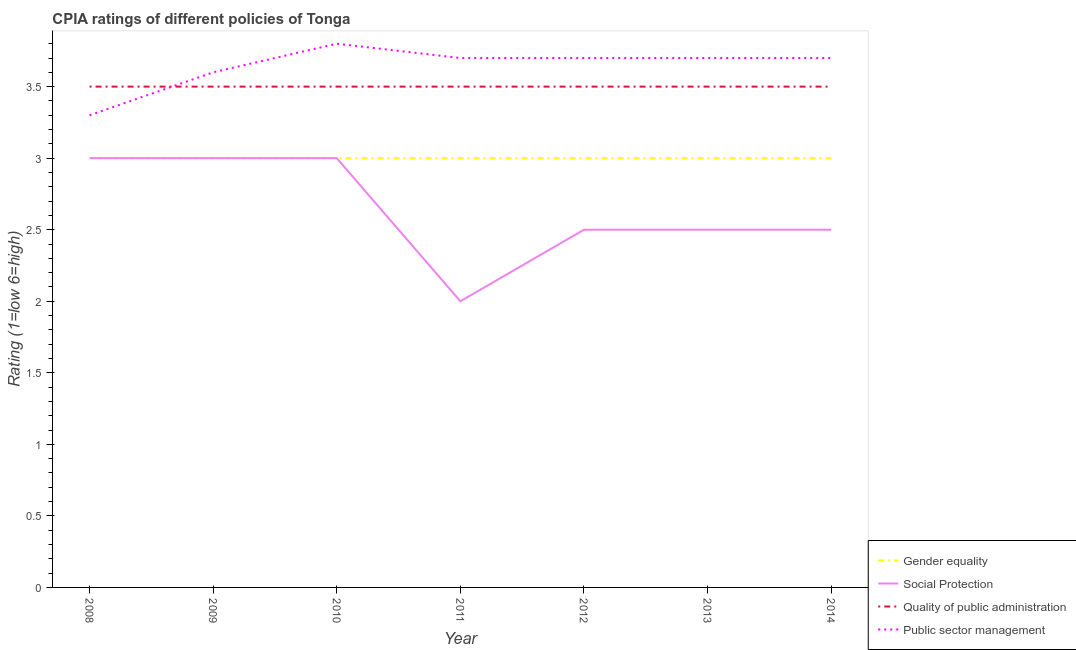How many different coloured lines are there?
Your answer should be very brief. 4. Is the number of lines equal to the number of legend labels?
Your answer should be compact. Yes. Across all years, what is the minimum cpia rating of quality of public administration?
Your answer should be compact. 3.5. In which year was the cpia rating of quality of public administration minimum?
Keep it short and to the point. 2008. What is the difference between the cpia rating of social protection in 2013 and that in 2014?
Provide a short and direct response. 0. What is the difference between the cpia rating of gender equality in 2009 and the cpia rating of quality of public administration in 2010?
Ensure brevity in your answer.  -0.5. What is the average cpia rating of public sector management per year?
Offer a terse response. 3.64. In the year 2009, what is the difference between the cpia rating of public sector management and cpia rating of gender equality?
Offer a very short reply. 0.6. In how many years, is the cpia rating of quality of public administration greater than 2.8?
Your answer should be compact. 7. Is the difference between the cpia rating of public sector management in 2013 and 2014 greater than the difference between the cpia rating of social protection in 2013 and 2014?
Make the answer very short. No. What is the difference between the highest and the second highest cpia rating of public sector management?
Offer a very short reply. 0.1. In how many years, is the cpia rating of gender equality greater than the average cpia rating of gender equality taken over all years?
Your answer should be compact. 0. Is it the case that in every year, the sum of the cpia rating of gender equality and cpia rating of social protection is greater than the cpia rating of quality of public administration?
Your answer should be very brief. Yes. How many years are there in the graph?
Ensure brevity in your answer.  7. What is the difference between two consecutive major ticks on the Y-axis?
Provide a succinct answer. 0.5. Are the values on the major ticks of Y-axis written in scientific E-notation?
Your answer should be very brief. No. How many legend labels are there?
Keep it short and to the point. 4. How are the legend labels stacked?
Provide a short and direct response. Vertical. What is the title of the graph?
Provide a short and direct response. CPIA ratings of different policies of Tonga. Does "Fiscal policy" appear as one of the legend labels in the graph?
Offer a terse response. No. What is the label or title of the X-axis?
Keep it short and to the point. Year. What is the Rating (1=low 6=high) in Social Protection in 2008?
Keep it short and to the point. 3. What is the Rating (1=low 6=high) of Quality of public administration in 2008?
Provide a short and direct response. 3.5. What is the Rating (1=low 6=high) in Public sector management in 2008?
Your answer should be compact. 3.3. What is the Rating (1=low 6=high) of Gender equality in 2009?
Offer a terse response. 3. What is the Rating (1=low 6=high) of Quality of public administration in 2009?
Give a very brief answer. 3.5. What is the Rating (1=low 6=high) in Public sector management in 2009?
Your response must be concise. 3.6. What is the Rating (1=low 6=high) of Social Protection in 2010?
Keep it short and to the point. 3. What is the Rating (1=low 6=high) in Quality of public administration in 2011?
Your answer should be compact. 3.5. What is the Rating (1=low 6=high) in Public sector management in 2011?
Make the answer very short. 3.7. What is the Rating (1=low 6=high) of Gender equality in 2012?
Your answer should be compact. 3. What is the Rating (1=low 6=high) of Quality of public administration in 2012?
Offer a terse response. 3.5. What is the Rating (1=low 6=high) of Public sector management in 2012?
Your response must be concise. 3.7. What is the Rating (1=low 6=high) of Gender equality in 2013?
Your response must be concise. 3. What is the Rating (1=low 6=high) in Gender equality in 2014?
Keep it short and to the point. 3. What is the Rating (1=low 6=high) in Social Protection in 2014?
Offer a terse response. 2.5. What is the Rating (1=low 6=high) in Quality of public administration in 2014?
Your answer should be very brief. 3.5. What is the Rating (1=low 6=high) of Public sector management in 2014?
Your response must be concise. 3.7. Across all years, what is the maximum Rating (1=low 6=high) of Gender equality?
Offer a terse response. 3. Across all years, what is the maximum Rating (1=low 6=high) in Social Protection?
Give a very brief answer. 3. Across all years, what is the maximum Rating (1=low 6=high) of Public sector management?
Keep it short and to the point. 3.8. Across all years, what is the minimum Rating (1=low 6=high) in Social Protection?
Your answer should be very brief. 2. Across all years, what is the minimum Rating (1=low 6=high) of Quality of public administration?
Provide a short and direct response. 3.5. What is the total Rating (1=low 6=high) in Social Protection in the graph?
Provide a short and direct response. 18.5. What is the difference between the Rating (1=low 6=high) in Gender equality in 2008 and that in 2009?
Provide a succinct answer. 0. What is the difference between the Rating (1=low 6=high) in Quality of public administration in 2008 and that in 2009?
Provide a short and direct response. 0. What is the difference between the Rating (1=low 6=high) of Gender equality in 2008 and that in 2010?
Your answer should be compact. 0. What is the difference between the Rating (1=low 6=high) of Social Protection in 2008 and that in 2010?
Your answer should be compact. 0. What is the difference between the Rating (1=low 6=high) in Public sector management in 2008 and that in 2010?
Provide a short and direct response. -0.5. What is the difference between the Rating (1=low 6=high) in Gender equality in 2008 and that in 2011?
Give a very brief answer. 0. What is the difference between the Rating (1=low 6=high) in Social Protection in 2008 and that in 2011?
Provide a short and direct response. 1. What is the difference between the Rating (1=low 6=high) of Quality of public administration in 2008 and that in 2011?
Provide a succinct answer. 0. What is the difference between the Rating (1=low 6=high) in Public sector management in 2008 and that in 2011?
Your response must be concise. -0.4. What is the difference between the Rating (1=low 6=high) of Gender equality in 2008 and that in 2012?
Provide a succinct answer. 0. What is the difference between the Rating (1=low 6=high) in Social Protection in 2008 and that in 2012?
Your answer should be very brief. 0.5. What is the difference between the Rating (1=low 6=high) of Quality of public administration in 2008 and that in 2012?
Your answer should be very brief. 0. What is the difference between the Rating (1=low 6=high) of Quality of public administration in 2008 and that in 2013?
Keep it short and to the point. 0. What is the difference between the Rating (1=low 6=high) of Public sector management in 2008 and that in 2013?
Provide a succinct answer. -0.4. What is the difference between the Rating (1=low 6=high) of Gender equality in 2009 and that in 2010?
Offer a very short reply. 0. What is the difference between the Rating (1=low 6=high) of Social Protection in 2009 and that in 2010?
Keep it short and to the point. 0. What is the difference between the Rating (1=low 6=high) in Quality of public administration in 2009 and that in 2010?
Make the answer very short. 0. What is the difference between the Rating (1=low 6=high) in Public sector management in 2009 and that in 2010?
Offer a terse response. -0.2. What is the difference between the Rating (1=low 6=high) of Gender equality in 2009 and that in 2011?
Give a very brief answer. 0. What is the difference between the Rating (1=low 6=high) of Gender equality in 2009 and that in 2012?
Make the answer very short. 0. What is the difference between the Rating (1=low 6=high) of Quality of public administration in 2009 and that in 2012?
Your response must be concise. 0. What is the difference between the Rating (1=low 6=high) of Public sector management in 2009 and that in 2012?
Your answer should be compact. -0.1. What is the difference between the Rating (1=low 6=high) of Social Protection in 2009 and that in 2013?
Ensure brevity in your answer.  0.5. What is the difference between the Rating (1=low 6=high) of Public sector management in 2009 and that in 2013?
Your answer should be compact. -0.1. What is the difference between the Rating (1=low 6=high) of Social Protection in 2009 and that in 2014?
Your answer should be compact. 0.5. What is the difference between the Rating (1=low 6=high) of Social Protection in 2010 and that in 2011?
Your response must be concise. 1. What is the difference between the Rating (1=low 6=high) of Quality of public administration in 2010 and that in 2011?
Your answer should be compact. 0. What is the difference between the Rating (1=low 6=high) of Gender equality in 2010 and that in 2012?
Provide a succinct answer. 0. What is the difference between the Rating (1=low 6=high) in Public sector management in 2010 and that in 2012?
Your answer should be very brief. 0.1. What is the difference between the Rating (1=low 6=high) in Gender equality in 2010 and that in 2013?
Your answer should be compact. 0. What is the difference between the Rating (1=low 6=high) in Social Protection in 2010 and that in 2014?
Your answer should be very brief. 0.5. What is the difference between the Rating (1=low 6=high) in Quality of public administration in 2010 and that in 2014?
Provide a succinct answer. 0. What is the difference between the Rating (1=low 6=high) of Gender equality in 2011 and that in 2012?
Offer a terse response. 0. What is the difference between the Rating (1=low 6=high) in Social Protection in 2011 and that in 2012?
Give a very brief answer. -0.5. What is the difference between the Rating (1=low 6=high) of Quality of public administration in 2011 and that in 2012?
Provide a short and direct response. 0. What is the difference between the Rating (1=low 6=high) of Public sector management in 2011 and that in 2013?
Give a very brief answer. 0. What is the difference between the Rating (1=low 6=high) in Social Protection in 2011 and that in 2014?
Ensure brevity in your answer.  -0.5. What is the difference between the Rating (1=low 6=high) in Quality of public administration in 2011 and that in 2014?
Your answer should be compact. 0. What is the difference between the Rating (1=low 6=high) in Gender equality in 2012 and that in 2013?
Make the answer very short. 0. What is the difference between the Rating (1=low 6=high) of Quality of public administration in 2012 and that in 2013?
Keep it short and to the point. 0. What is the difference between the Rating (1=low 6=high) of Public sector management in 2012 and that in 2013?
Ensure brevity in your answer.  0. What is the difference between the Rating (1=low 6=high) of Gender equality in 2012 and that in 2014?
Provide a short and direct response. 0. What is the difference between the Rating (1=low 6=high) of Quality of public administration in 2012 and that in 2014?
Provide a short and direct response. 0. What is the difference between the Rating (1=low 6=high) of Public sector management in 2013 and that in 2014?
Your response must be concise. 0. What is the difference between the Rating (1=low 6=high) of Gender equality in 2008 and the Rating (1=low 6=high) of Social Protection in 2009?
Your answer should be compact. 0. What is the difference between the Rating (1=low 6=high) of Gender equality in 2008 and the Rating (1=low 6=high) of Public sector management in 2009?
Offer a terse response. -0.6. What is the difference between the Rating (1=low 6=high) in Gender equality in 2008 and the Rating (1=low 6=high) in Quality of public administration in 2010?
Offer a terse response. -0.5. What is the difference between the Rating (1=low 6=high) of Social Protection in 2008 and the Rating (1=low 6=high) of Quality of public administration in 2010?
Your answer should be compact. -0.5. What is the difference between the Rating (1=low 6=high) of Social Protection in 2008 and the Rating (1=low 6=high) of Public sector management in 2010?
Provide a short and direct response. -0.8. What is the difference between the Rating (1=low 6=high) in Quality of public administration in 2008 and the Rating (1=low 6=high) in Public sector management in 2010?
Ensure brevity in your answer.  -0.3. What is the difference between the Rating (1=low 6=high) in Gender equality in 2008 and the Rating (1=low 6=high) in Social Protection in 2011?
Provide a short and direct response. 1. What is the difference between the Rating (1=low 6=high) of Gender equality in 2008 and the Rating (1=low 6=high) of Public sector management in 2011?
Your response must be concise. -0.7. What is the difference between the Rating (1=low 6=high) in Social Protection in 2008 and the Rating (1=low 6=high) in Public sector management in 2011?
Ensure brevity in your answer.  -0.7. What is the difference between the Rating (1=low 6=high) in Quality of public administration in 2008 and the Rating (1=low 6=high) in Public sector management in 2011?
Offer a terse response. -0.2. What is the difference between the Rating (1=low 6=high) of Gender equality in 2008 and the Rating (1=low 6=high) of Social Protection in 2012?
Your response must be concise. 0.5. What is the difference between the Rating (1=low 6=high) of Gender equality in 2008 and the Rating (1=low 6=high) of Public sector management in 2012?
Give a very brief answer. -0.7. What is the difference between the Rating (1=low 6=high) of Social Protection in 2008 and the Rating (1=low 6=high) of Public sector management in 2012?
Your response must be concise. -0.7. What is the difference between the Rating (1=low 6=high) in Quality of public administration in 2008 and the Rating (1=low 6=high) in Public sector management in 2012?
Keep it short and to the point. -0.2. What is the difference between the Rating (1=low 6=high) of Gender equality in 2008 and the Rating (1=low 6=high) of Social Protection in 2013?
Offer a terse response. 0.5. What is the difference between the Rating (1=low 6=high) in Gender equality in 2008 and the Rating (1=low 6=high) in Public sector management in 2013?
Provide a short and direct response. -0.7. What is the difference between the Rating (1=low 6=high) in Gender equality in 2008 and the Rating (1=low 6=high) in Social Protection in 2014?
Your response must be concise. 0.5. What is the difference between the Rating (1=low 6=high) in Gender equality in 2008 and the Rating (1=low 6=high) in Quality of public administration in 2014?
Offer a very short reply. -0.5. What is the difference between the Rating (1=low 6=high) in Social Protection in 2008 and the Rating (1=low 6=high) in Quality of public administration in 2014?
Make the answer very short. -0.5. What is the difference between the Rating (1=low 6=high) in Quality of public administration in 2008 and the Rating (1=low 6=high) in Public sector management in 2014?
Give a very brief answer. -0.2. What is the difference between the Rating (1=low 6=high) in Gender equality in 2009 and the Rating (1=low 6=high) in Social Protection in 2010?
Your answer should be compact. 0. What is the difference between the Rating (1=low 6=high) of Gender equality in 2009 and the Rating (1=low 6=high) of Quality of public administration in 2010?
Keep it short and to the point. -0.5. What is the difference between the Rating (1=low 6=high) in Social Protection in 2009 and the Rating (1=low 6=high) in Public sector management in 2010?
Offer a terse response. -0.8. What is the difference between the Rating (1=low 6=high) of Gender equality in 2009 and the Rating (1=low 6=high) of Public sector management in 2011?
Your response must be concise. -0.7. What is the difference between the Rating (1=low 6=high) in Quality of public administration in 2009 and the Rating (1=low 6=high) in Public sector management in 2011?
Give a very brief answer. -0.2. What is the difference between the Rating (1=low 6=high) in Gender equality in 2009 and the Rating (1=low 6=high) in Quality of public administration in 2012?
Your response must be concise. -0.5. What is the difference between the Rating (1=low 6=high) of Gender equality in 2009 and the Rating (1=low 6=high) of Public sector management in 2012?
Offer a terse response. -0.7. What is the difference between the Rating (1=low 6=high) in Social Protection in 2009 and the Rating (1=low 6=high) in Public sector management in 2012?
Ensure brevity in your answer.  -0.7. What is the difference between the Rating (1=low 6=high) in Quality of public administration in 2009 and the Rating (1=low 6=high) in Public sector management in 2012?
Ensure brevity in your answer.  -0.2. What is the difference between the Rating (1=low 6=high) in Gender equality in 2009 and the Rating (1=low 6=high) in Quality of public administration in 2013?
Give a very brief answer. -0.5. What is the difference between the Rating (1=low 6=high) in Gender equality in 2009 and the Rating (1=low 6=high) in Public sector management in 2013?
Provide a short and direct response. -0.7. What is the difference between the Rating (1=low 6=high) of Quality of public administration in 2009 and the Rating (1=low 6=high) of Public sector management in 2013?
Make the answer very short. -0.2. What is the difference between the Rating (1=low 6=high) in Social Protection in 2009 and the Rating (1=low 6=high) in Public sector management in 2014?
Your response must be concise. -0.7. What is the difference between the Rating (1=low 6=high) in Social Protection in 2010 and the Rating (1=low 6=high) in Quality of public administration in 2011?
Provide a short and direct response. -0.5. What is the difference between the Rating (1=low 6=high) of Social Protection in 2010 and the Rating (1=low 6=high) of Public sector management in 2011?
Offer a very short reply. -0.7. What is the difference between the Rating (1=low 6=high) of Gender equality in 2010 and the Rating (1=low 6=high) of Social Protection in 2012?
Your answer should be very brief. 0.5. What is the difference between the Rating (1=low 6=high) in Gender equality in 2010 and the Rating (1=low 6=high) in Quality of public administration in 2012?
Your response must be concise. -0.5. What is the difference between the Rating (1=low 6=high) in Social Protection in 2010 and the Rating (1=low 6=high) in Public sector management in 2012?
Offer a terse response. -0.7. What is the difference between the Rating (1=low 6=high) in Gender equality in 2010 and the Rating (1=low 6=high) in Quality of public administration in 2013?
Ensure brevity in your answer.  -0.5. What is the difference between the Rating (1=low 6=high) of Gender equality in 2010 and the Rating (1=low 6=high) of Public sector management in 2013?
Keep it short and to the point. -0.7. What is the difference between the Rating (1=low 6=high) of Quality of public administration in 2010 and the Rating (1=low 6=high) of Public sector management in 2013?
Give a very brief answer. -0.2. What is the difference between the Rating (1=low 6=high) in Gender equality in 2010 and the Rating (1=low 6=high) in Social Protection in 2014?
Your answer should be very brief. 0.5. What is the difference between the Rating (1=low 6=high) of Gender equality in 2010 and the Rating (1=low 6=high) of Quality of public administration in 2014?
Provide a short and direct response. -0.5. What is the difference between the Rating (1=low 6=high) in Gender equality in 2010 and the Rating (1=low 6=high) in Public sector management in 2014?
Keep it short and to the point. -0.7. What is the difference between the Rating (1=low 6=high) of Quality of public administration in 2010 and the Rating (1=low 6=high) of Public sector management in 2014?
Your response must be concise. -0.2. What is the difference between the Rating (1=low 6=high) of Gender equality in 2011 and the Rating (1=low 6=high) of Public sector management in 2012?
Keep it short and to the point. -0.7. What is the difference between the Rating (1=low 6=high) in Quality of public administration in 2011 and the Rating (1=low 6=high) in Public sector management in 2012?
Your response must be concise. -0.2. What is the difference between the Rating (1=low 6=high) in Gender equality in 2011 and the Rating (1=low 6=high) in Quality of public administration in 2013?
Provide a short and direct response. -0.5. What is the difference between the Rating (1=low 6=high) of Quality of public administration in 2011 and the Rating (1=low 6=high) of Public sector management in 2013?
Make the answer very short. -0.2. What is the difference between the Rating (1=low 6=high) in Gender equality in 2011 and the Rating (1=low 6=high) in Social Protection in 2014?
Your response must be concise. 0.5. What is the difference between the Rating (1=low 6=high) of Social Protection in 2011 and the Rating (1=low 6=high) of Quality of public administration in 2014?
Make the answer very short. -1.5. What is the difference between the Rating (1=low 6=high) of Social Protection in 2011 and the Rating (1=low 6=high) of Public sector management in 2014?
Your answer should be very brief. -1.7. What is the difference between the Rating (1=low 6=high) of Quality of public administration in 2011 and the Rating (1=low 6=high) of Public sector management in 2014?
Provide a succinct answer. -0.2. What is the difference between the Rating (1=low 6=high) in Social Protection in 2012 and the Rating (1=low 6=high) in Public sector management in 2013?
Give a very brief answer. -1.2. What is the difference between the Rating (1=low 6=high) in Quality of public administration in 2012 and the Rating (1=low 6=high) in Public sector management in 2013?
Provide a short and direct response. -0.2. What is the difference between the Rating (1=low 6=high) in Gender equality in 2012 and the Rating (1=low 6=high) in Quality of public administration in 2014?
Provide a short and direct response. -0.5. What is the difference between the Rating (1=low 6=high) of Gender equality in 2012 and the Rating (1=low 6=high) of Public sector management in 2014?
Offer a very short reply. -0.7. What is the difference between the Rating (1=low 6=high) in Social Protection in 2012 and the Rating (1=low 6=high) in Public sector management in 2014?
Your answer should be compact. -1.2. What is the difference between the Rating (1=low 6=high) in Quality of public administration in 2012 and the Rating (1=low 6=high) in Public sector management in 2014?
Provide a succinct answer. -0.2. What is the difference between the Rating (1=low 6=high) of Gender equality in 2013 and the Rating (1=low 6=high) of Social Protection in 2014?
Offer a very short reply. 0.5. What is the difference between the Rating (1=low 6=high) of Gender equality in 2013 and the Rating (1=low 6=high) of Public sector management in 2014?
Ensure brevity in your answer.  -0.7. What is the difference between the Rating (1=low 6=high) of Social Protection in 2013 and the Rating (1=low 6=high) of Quality of public administration in 2014?
Your answer should be very brief. -1. What is the difference between the Rating (1=low 6=high) of Quality of public administration in 2013 and the Rating (1=low 6=high) of Public sector management in 2014?
Make the answer very short. -0.2. What is the average Rating (1=low 6=high) of Gender equality per year?
Offer a terse response. 3. What is the average Rating (1=low 6=high) of Social Protection per year?
Offer a very short reply. 2.64. What is the average Rating (1=low 6=high) of Quality of public administration per year?
Offer a very short reply. 3.5. What is the average Rating (1=low 6=high) in Public sector management per year?
Your answer should be very brief. 3.64. In the year 2008, what is the difference between the Rating (1=low 6=high) of Gender equality and Rating (1=low 6=high) of Quality of public administration?
Give a very brief answer. -0.5. In the year 2008, what is the difference between the Rating (1=low 6=high) in Social Protection and Rating (1=low 6=high) in Quality of public administration?
Keep it short and to the point. -0.5. In the year 2008, what is the difference between the Rating (1=low 6=high) of Quality of public administration and Rating (1=low 6=high) of Public sector management?
Provide a short and direct response. 0.2. In the year 2009, what is the difference between the Rating (1=low 6=high) in Gender equality and Rating (1=low 6=high) in Social Protection?
Keep it short and to the point. 0. In the year 2009, what is the difference between the Rating (1=low 6=high) of Gender equality and Rating (1=low 6=high) of Quality of public administration?
Make the answer very short. -0.5. In the year 2009, what is the difference between the Rating (1=low 6=high) of Gender equality and Rating (1=low 6=high) of Public sector management?
Offer a terse response. -0.6. In the year 2009, what is the difference between the Rating (1=low 6=high) in Social Protection and Rating (1=low 6=high) in Public sector management?
Offer a terse response. -0.6. In the year 2009, what is the difference between the Rating (1=low 6=high) of Quality of public administration and Rating (1=low 6=high) of Public sector management?
Your answer should be compact. -0.1. In the year 2010, what is the difference between the Rating (1=low 6=high) in Gender equality and Rating (1=low 6=high) in Social Protection?
Ensure brevity in your answer.  0. In the year 2010, what is the difference between the Rating (1=low 6=high) of Gender equality and Rating (1=low 6=high) of Public sector management?
Provide a short and direct response. -0.8. In the year 2010, what is the difference between the Rating (1=low 6=high) in Social Protection and Rating (1=low 6=high) in Quality of public administration?
Provide a succinct answer. -0.5. In the year 2011, what is the difference between the Rating (1=low 6=high) of Gender equality and Rating (1=low 6=high) of Quality of public administration?
Provide a succinct answer. -0.5. In the year 2011, what is the difference between the Rating (1=low 6=high) in Gender equality and Rating (1=low 6=high) in Public sector management?
Ensure brevity in your answer.  -0.7. In the year 2011, what is the difference between the Rating (1=low 6=high) in Quality of public administration and Rating (1=low 6=high) in Public sector management?
Provide a short and direct response. -0.2. In the year 2012, what is the difference between the Rating (1=low 6=high) in Social Protection and Rating (1=low 6=high) in Quality of public administration?
Offer a very short reply. -1. In the year 2013, what is the difference between the Rating (1=low 6=high) in Gender equality and Rating (1=low 6=high) in Social Protection?
Offer a terse response. 0.5. In the year 2013, what is the difference between the Rating (1=low 6=high) of Gender equality and Rating (1=low 6=high) of Quality of public administration?
Make the answer very short. -0.5. In the year 2013, what is the difference between the Rating (1=low 6=high) in Social Protection and Rating (1=low 6=high) in Public sector management?
Make the answer very short. -1.2. In the year 2014, what is the difference between the Rating (1=low 6=high) of Gender equality and Rating (1=low 6=high) of Public sector management?
Provide a succinct answer. -0.7. In the year 2014, what is the difference between the Rating (1=low 6=high) of Social Protection and Rating (1=low 6=high) of Quality of public administration?
Give a very brief answer. -1. In the year 2014, what is the difference between the Rating (1=low 6=high) in Quality of public administration and Rating (1=low 6=high) in Public sector management?
Give a very brief answer. -0.2. What is the ratio of the Rating (1=low 6=high) of Social Protection in 2008 to that in 2009?
Provide a short and direct response. 1. What is the ratio of the Rating (1=low 6=high) in Quality of public administration in 2008 to that in 2009?
Give a very brief answer. 1. What is the ratio of the Rating (1=low 6=high) of Public sector management in 2008 to that in 2010?
Keep it short and to the point. 0.87. What is the ratio of the Rating (1=low 6=high) in Social Protection in 2008 to that in 2011?
Provide a short and direct response. 1.5. What is the ratio of the Rating (1=low 6=high) of Quality of public administration in 2008 to that in 2011?
Give a very brief answer. 1. What is the ratio of the Rating (1=low 6=high) in Public sector management in 2008 to that in 2011?
Make the answer very short. 0.89. What is the ratio of the Rating (1=low 6=high) in Quality of public administration in 2008 to that in 2012?
Offer a terse response. 1. What is the ratio of the Rating (1=low 6=high) of Public sector management in 2008 to that in 2012?
Your answer should be compact. 0.89. What is the ratio of the Rating (1=low 6=high) in Gender equality in 2008 to that in 2013?
Make the answer very short. 1. What is the ratio of the Rating (1=low 6=high) of Quality of public administration in 2008 to that in 2013?
Offer a very short reply. 1. What is the ratio of the Rating (1=low 6=high) of Public sector management in 2008 to that in 2013?
Offer a terse response. 0.89. What is the ratio of the Rating (1=low 6=high) of Gender equality in 2008 to that in 2014?
Offer a terse response. 1. What is the ratio of the Rating (1=low 6=high) of Quality of public administration in 2008 to that in 2014?
Provide a short and direct response. 1. What is the ratio of the Rating (1=low 6=high) of Public sector management in 2008 to that in 2014?
Your response must be concise. 0.89. What is the ratio of the Rating (1=low 6=high) in Gender equality in 2009 to that in 2010?
Offer a terse response. 1. What is the ratio of the Rating (1=low 6=high) in Quality of public administration in 2009 to that in 2010?
Your answer should be very brief. 1. What is the ratio of the Rating (1=low 6=high) of Gender equality in 2009 to that in 2011?
Your answer should be very brief. 1. What is the ratio of the Rating (1=low 6=high) of Social Protection in 2009 to that in 2011?
Provide a short and direct response. 1.5. What is the ratio of the Rating (1=low 6=high) of Quality of public administration in 2009 to that in 2011?
Make the answer very short. 1. What is the ratio of the Rating (1=low 6=high) of Public sector management in 2009 to that in 2011?
Provide a succinct answer. 0.97. What is the ratio of the Rating (1=low 6=high) in Social Protection in 2009 to that in 2012?
Keep it short and to the point. 1.2. What is the ratio of the Rating (1=low 6=high) of Public sector management in 2009 to that in 2012?
Your response must be concise. 0.97. What is the ratio of the Rating (1=low 6=high) in Gender equality in 2009 to that in 2013?
Your answer should be very brief. 1. What is the ratio of the Rating (1=low 6=high) in Social Protection in 2009 to that in 2013?
Provide a short and direct response. 1.2. What is the ratio of the Rating (1=low 6=high) of Public sector management in 2009 to that in 2014?
Make the answer very short. 0.97. What is the ratio of the Rating (1=low 6=high) of Gender equality in 2010 to that in 2011?
Your answer should be compact. 1. What is the ratio of the Rating (1=low 6=high) of Quality of public administration in 2010 to that in 2011?
Give a very brief answer. 1. What is the ratio of the Rating (1=low 6=high) in Social Protection in 2010 to that in 2012?
Give a very brief answer. 1.2. What is the ratio of the Rating (1=low 6=high) in Quality of public administration in 2010 to that in 2012?
Offer a terse response. 1. What is the ratio of the Rating (1=low 6=high) of Quality of public administration in 2010 to that in 2013?
Give a very brief answer. 1. What is the ratio of the Rating (1=low 6=high) of Public sector management in 2010 to that in 2013?
Keep it short and to the point. 1.03. What is the ratio of the Rating (1=low 6=high) in Gender equality in 2010 to that in 2014?
Keep it short and to the point. 1. What is the ratio of the Rating (1=low 6=high) in Quality of public administration in 2010 to that in 2014?
Keep it short and to the point. 1. What is the ratio of the Rating (1=low 6=high) in Quality of public administration in 2011 to that in 2012?
Your answer should be very brief. 1. What is the ratio of the Rating (1=low 6=high) of Public sector management in 2011 to that in 2012?
Keep it short and to the point. 1. What is the ratio of the Rating (1=low 6=high) of Public sector management in 2011 to that in 2013?
Your answer should be compact. 1. What is the ratio of the Rating (1=low 6=high) of Gender equality in 2011 to that in 2014?
Provide a short and direct response. 1. What is the ratio of the Rating (1=low 6=high) of Social Protection in 2011 to that in 2014?
Make the answer very short. 0.8. What is the ratio of the Rating (1=low 6=high) of Social Protection in 2012 to that in 2013?
Provide a short and direct response. 1. What is the ratio of the Rating (1=low 6=high) of Quality of public administration in 2012 to that in 2013?
Give a very brief answer. 1. What is the ratio of the Rating (1=low 6=high) in Gender equality in 2012 to that in 2014?
Your answer should be compact. 1. What is the ratio of the Rating (1=low 6=high) in Social Protection in 2012 to that in 2014?
Offer a very short reply. 1. What is the difference between the highest and the second highest Rating (1=low 6=high) in Gender equality?
Give a very brief answer. 0. What is the difference between the highest and the second highest Rating (1=low 6=high) of Quality of public administration?
Offer a very short reply. 0. 